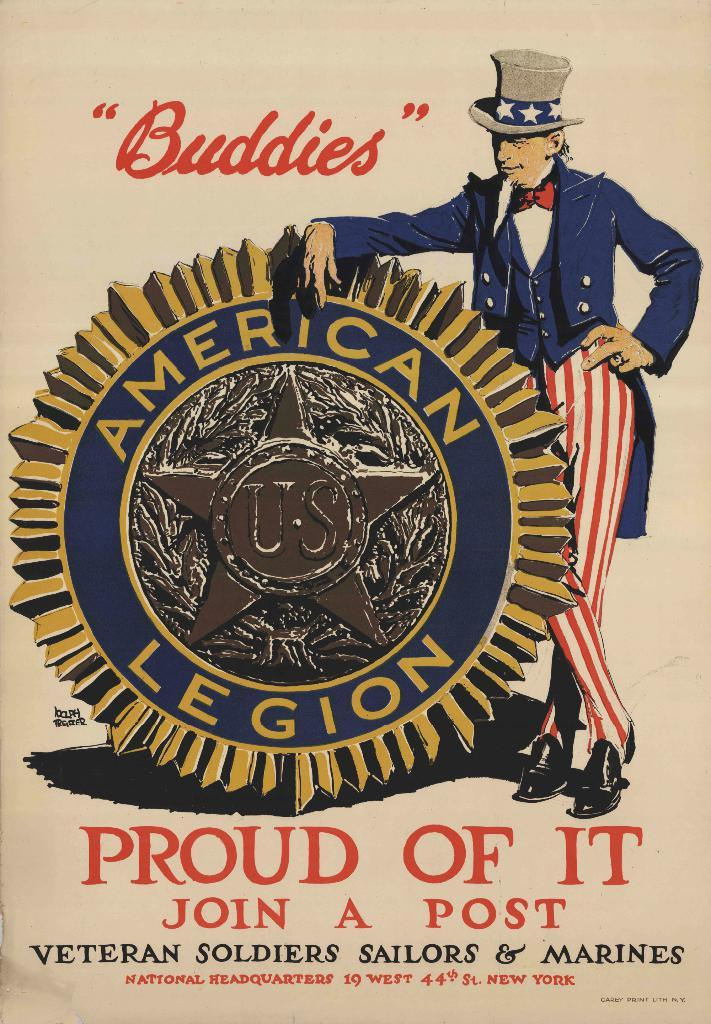<image>
Present a compact description of the photo's key features. Uncle Sam has his arm over a medal that says AMERICAN LEGION on it on an illustrated poster. 